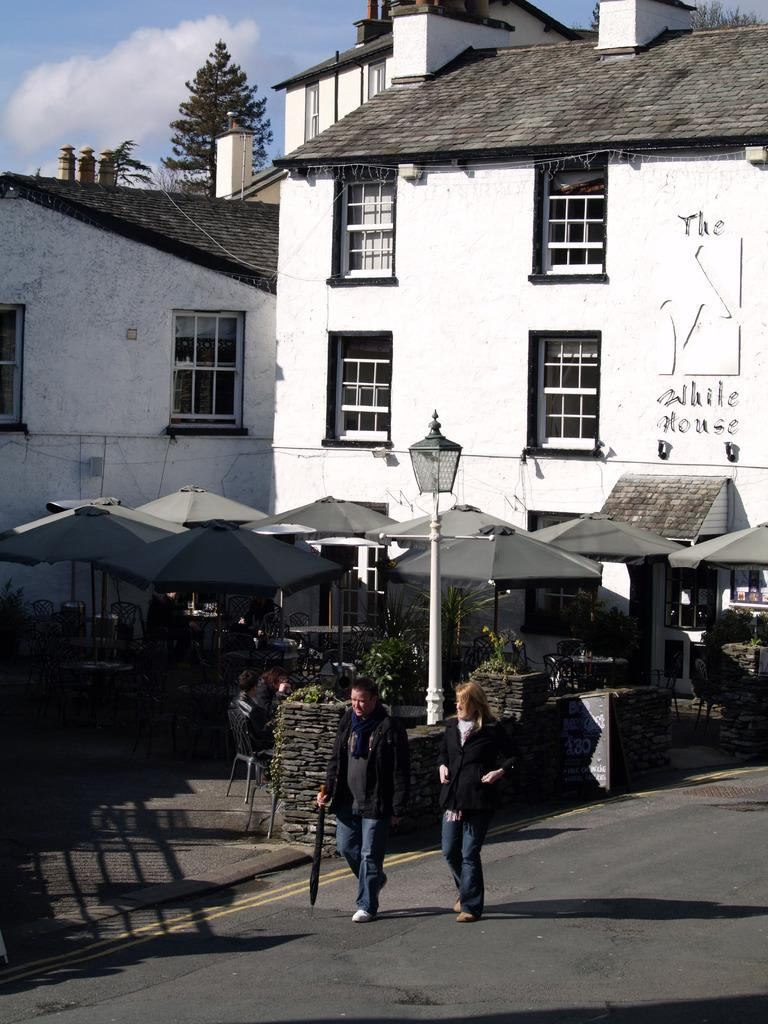What are the people in the image doing? The people in the image are walking on the road. What can be seen in the background of the image? There are buildings, stalls, trees, and the sky visible in the background. Can you describe the objects present in the background? There are other objects present in the background, but their specific details are not mentioned in the provided facts. What religious request is being made by the people in the image? There is no indication of any religious activity or request in the image. What type of music can be heard in the background of the image? There is no mention of any music or sound in the image. 